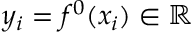Convert formula to latex. <formula><loc_0><loc_0><loc_500><loc_500>y _ { i } = f ^ { 0 } ( x _ { i } ) \in \mathbb { R }</formula> 